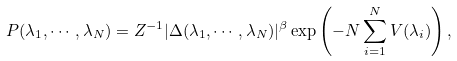Convert formula to latex. <formula><loc_0><loc_0><loc_500><loc_500>P ( \lambda _ { 1 } , \cdots , \lambda _ { N } ) = Z ^ { - 1 } | \Delta ( \lambda _ { 1 } , \cdots , \lambda _ { N } ) | ^ { \beta } \exp \left ( - N \sum _ { i = 1 } ^ { N } V ( \lambda _ { i } ) \right ) ,</formula> 